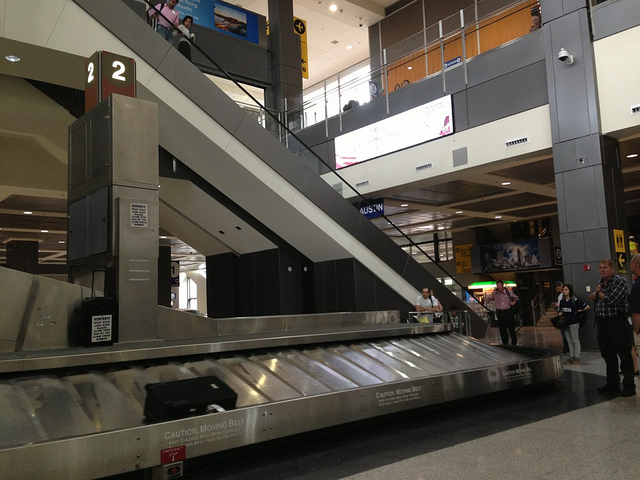<image>What is the yellow line for? There is no yellow line in the image. However, it could potentially indicate 'caution' or 'do not cross' if it were present. What is the yellow line for? I don't know what the yellow line is for. It can be used for various purposes such as caution, dividing, or safety. 